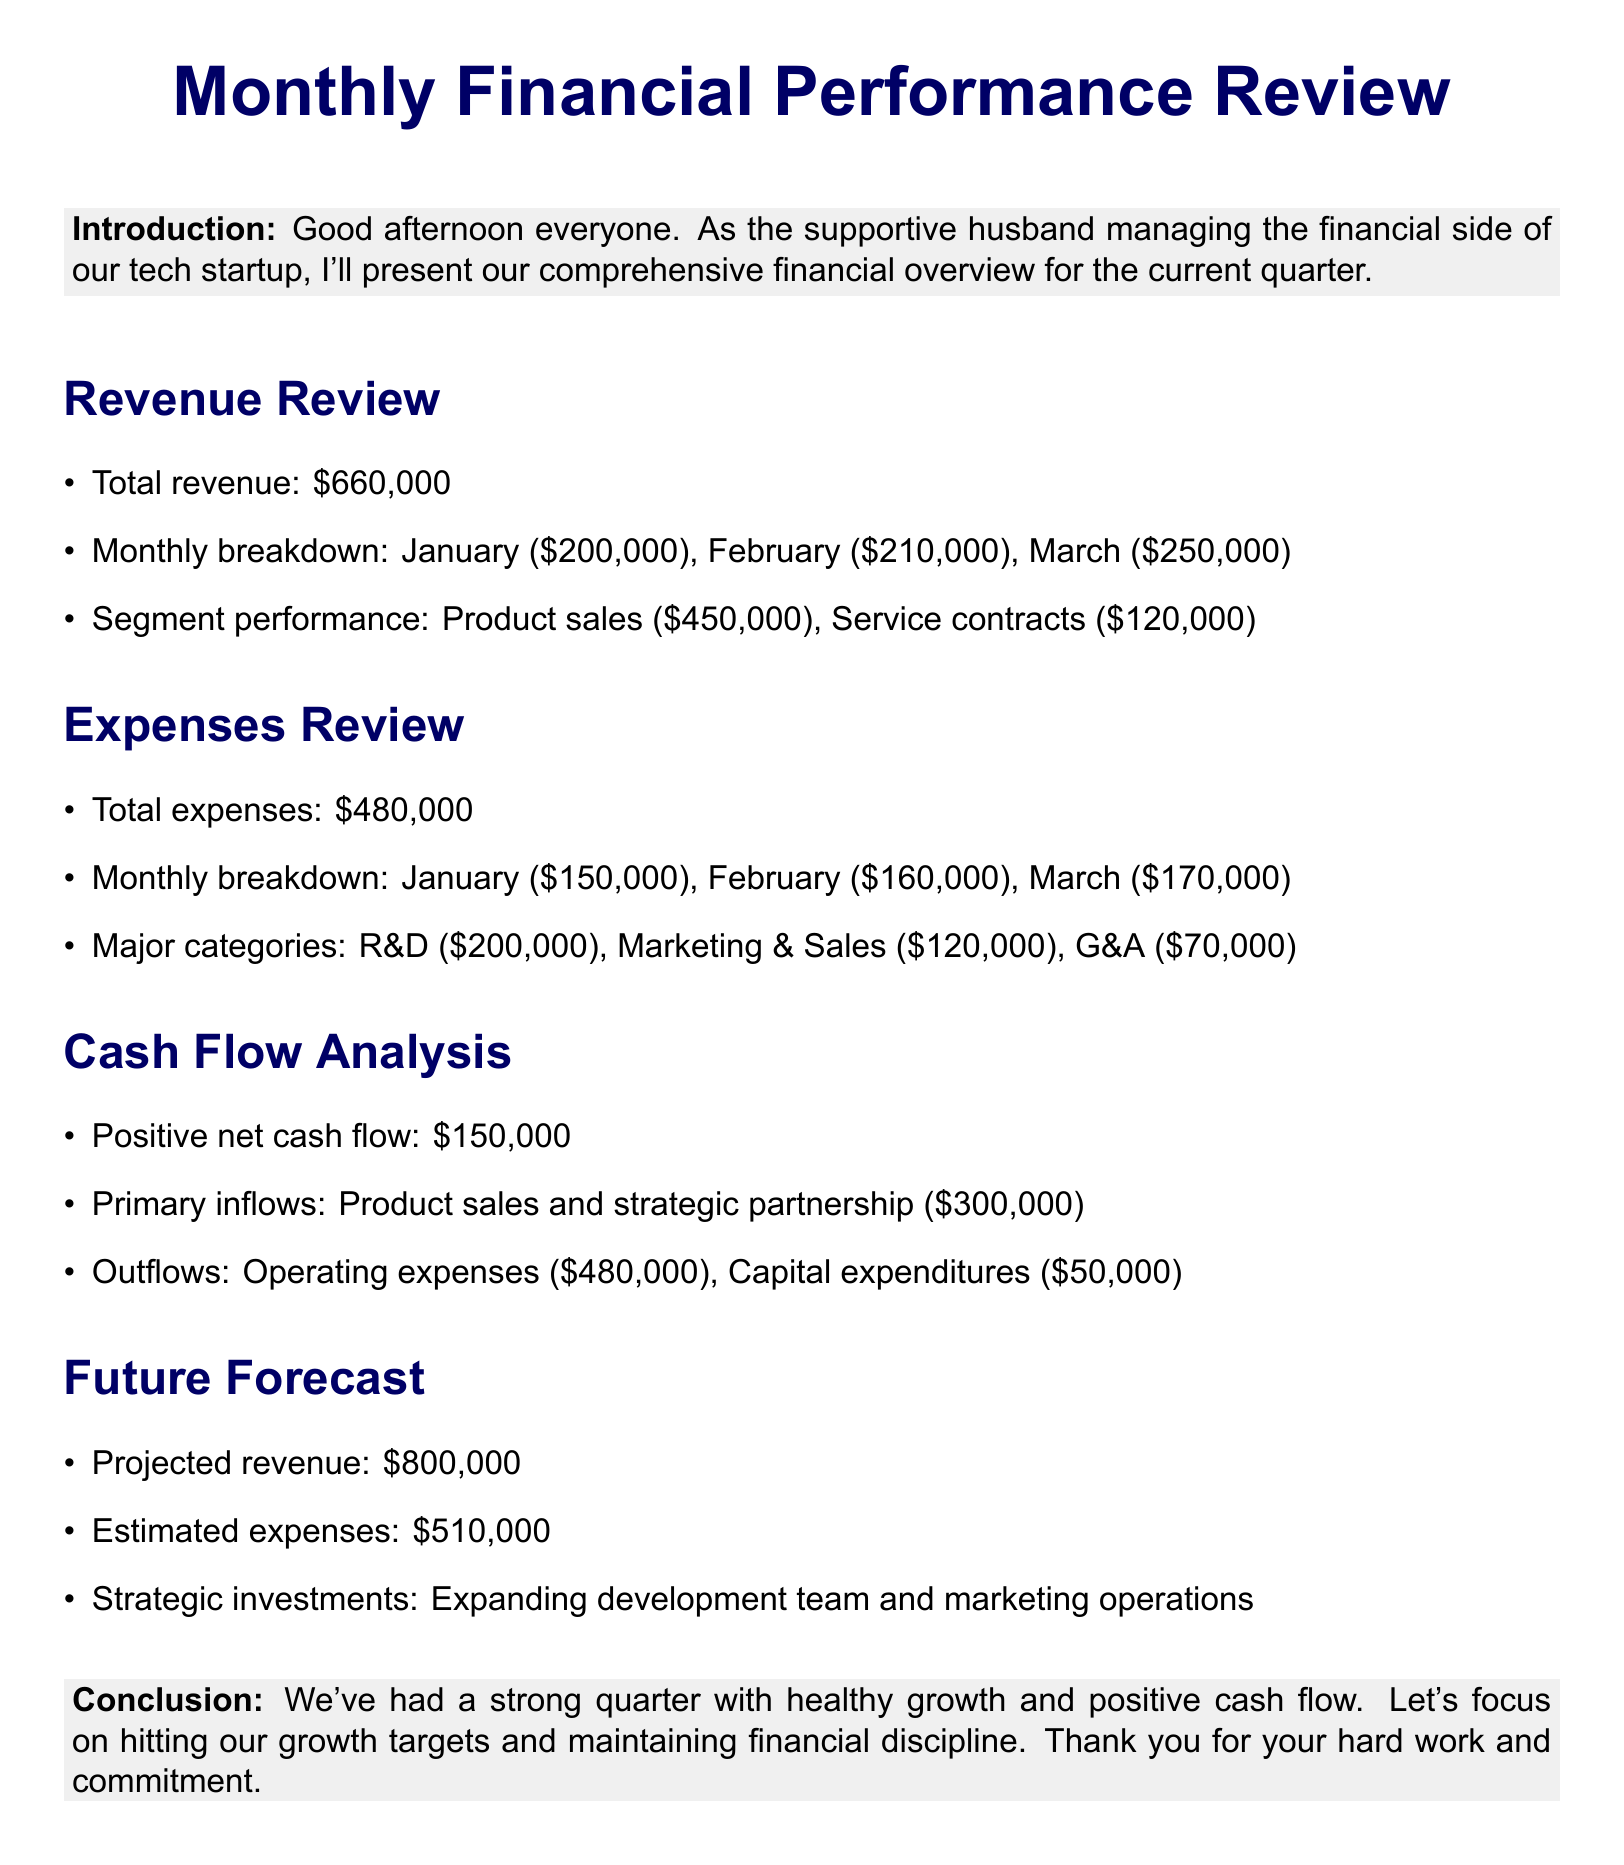What is the total revenue? The total revenue is the sum of all monthly revenues provided in the document, which is $200,000 + $210,000 + $250,000 = $660,000.
Answer: $660,000 What were the expenses in March? The document states the expenses for each month, and for March, it was $170,000.
Answer: $170,000 What is the net cash flow for the quarter? Net cash flow is mentioned in the Cash Flow Analysis section and is reported as positive $150,000.
Answer: $150,000 How much was spent on R&D? The document highlights major expense categories, stating that R&D costs were $200,000.
Answer: $200,000 What is the projected revenue for the next quarter? The Future Forecast section estimates revenue to be $800,000.
Answer: $800,000 What is the total of service contracts revenue? The document indicates that revenue from service contracts totaled $120,000.
Answer: $120,000 What amount is allocated for capital expenditures? The outflows section mentions capital expenditures totaling $50,000.
Answer: $50,000 What is the estimated expense for the next quarter? The document projects future expenses to be $510,000.
Answer: $510,000 What was the revenue from product sales? The document specifies revenue from product sales to be $450,000.
Answer: $450,000 What strategic initiatives are planned? The Future Forecast section mentions that investments will focus on expanding the development team and marketing operations.
Answer: Expanding development team and marketing operations 